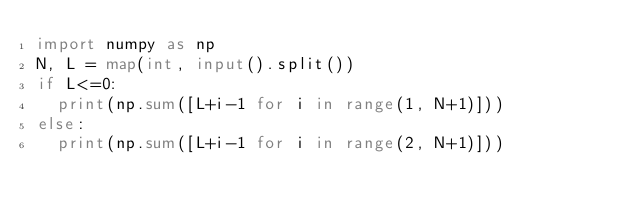Convert code to text. <code><loc_0><loc_0><loc_500><loc_500><_Python_>import numpy as np
N, L = map(int, input().split())
if L<=0:
  print(np.sum([L+i-1 for i in range(1, N+1)]))
else:
  print(np.sum([L+i-1 for i in range(2, N+1)]))</code> 